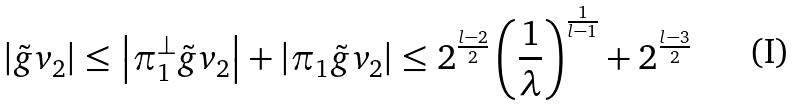Convert formula to latex. <formula><loc_0><loc_0><loc_500><loc_500>\left | \tilde { g } v _ { 2 } \right | \leq \left | \pi ^ { \perp } _ { 1 } \tilde { g } v _ { 2 } \right | + \left | \pi _ { 1 } \tilde { g } v _ { 2 } \right | \leq 2 ^ { \frac { l - 2 } { 2 } } \left ( \frac { 1 } { \lambda } \right ) ^ { \frac { 1 } { l - 1 } } + 2 ^ { \frac { l - 3 } { 2 } }</formula> 